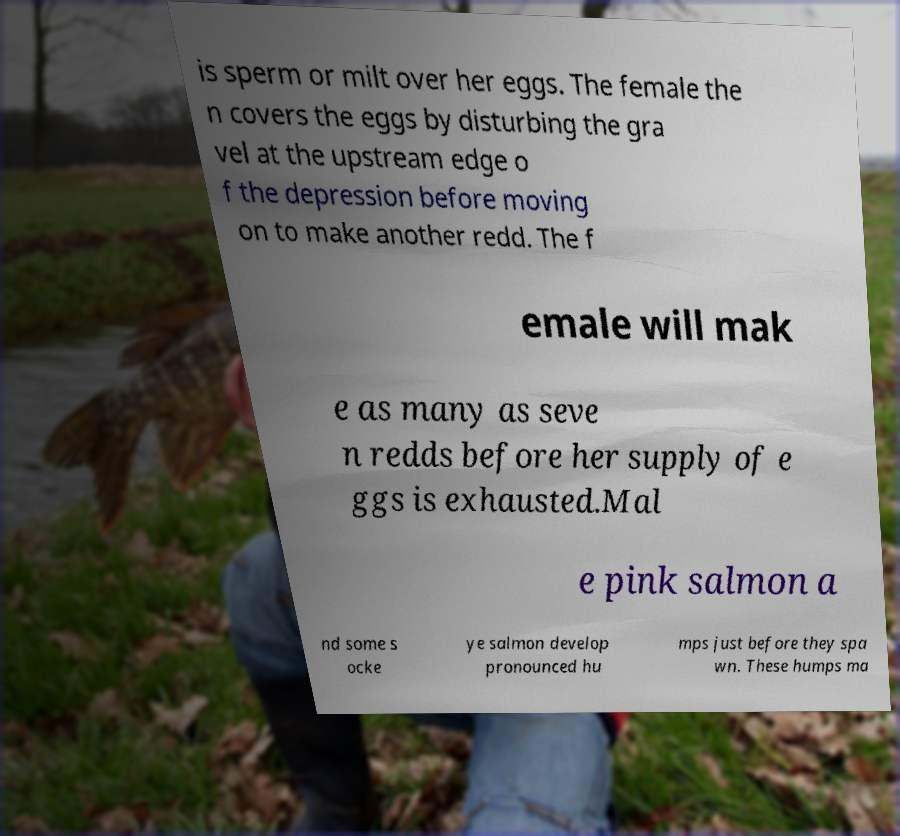Can you accurately transcribe the text from the provided image for me? is sperm or milt over her eggs. The female the n covers the eggs by disturbing the gra vel at the upstream edge o f the depression before moving on to make another redd. The f emale will mak e as many as seve n redds before her supply of e ggs is exhausted.Mal e pink salmon a nd some s ocke ye salmon develop pronounced hu mps just before they spa wn. These humps ma 